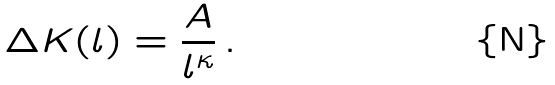<formula> <loc_0><loc_0><loc_500><loc_500>\Delta K ( l ) = \frac { A } { l ^ { \kappa } } \, .</formula> 